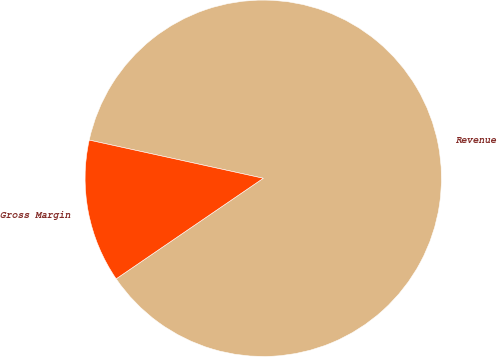Convert chart to OTSL. <chart><loc_0><loc_0><loc_500><loc_500><pie_chart><fcel>Revenue<fcel>Gross Margin<nl><fcel>87.02%<fcel>12.98%<nl></chart> 